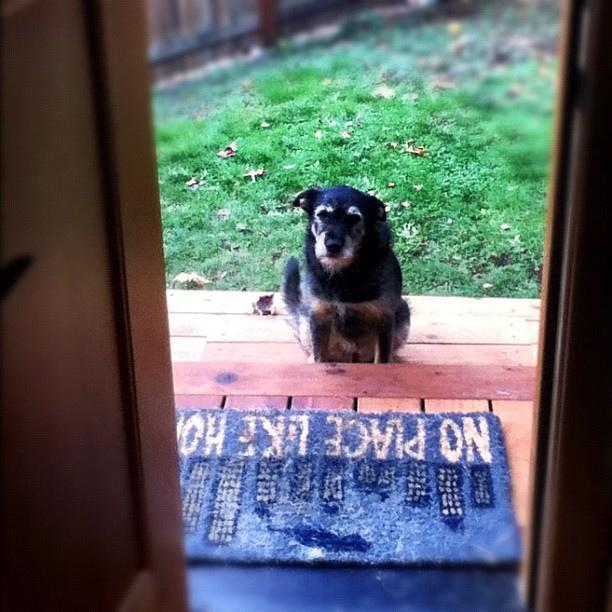How many people are there?
Give a very brief answer. 0. 